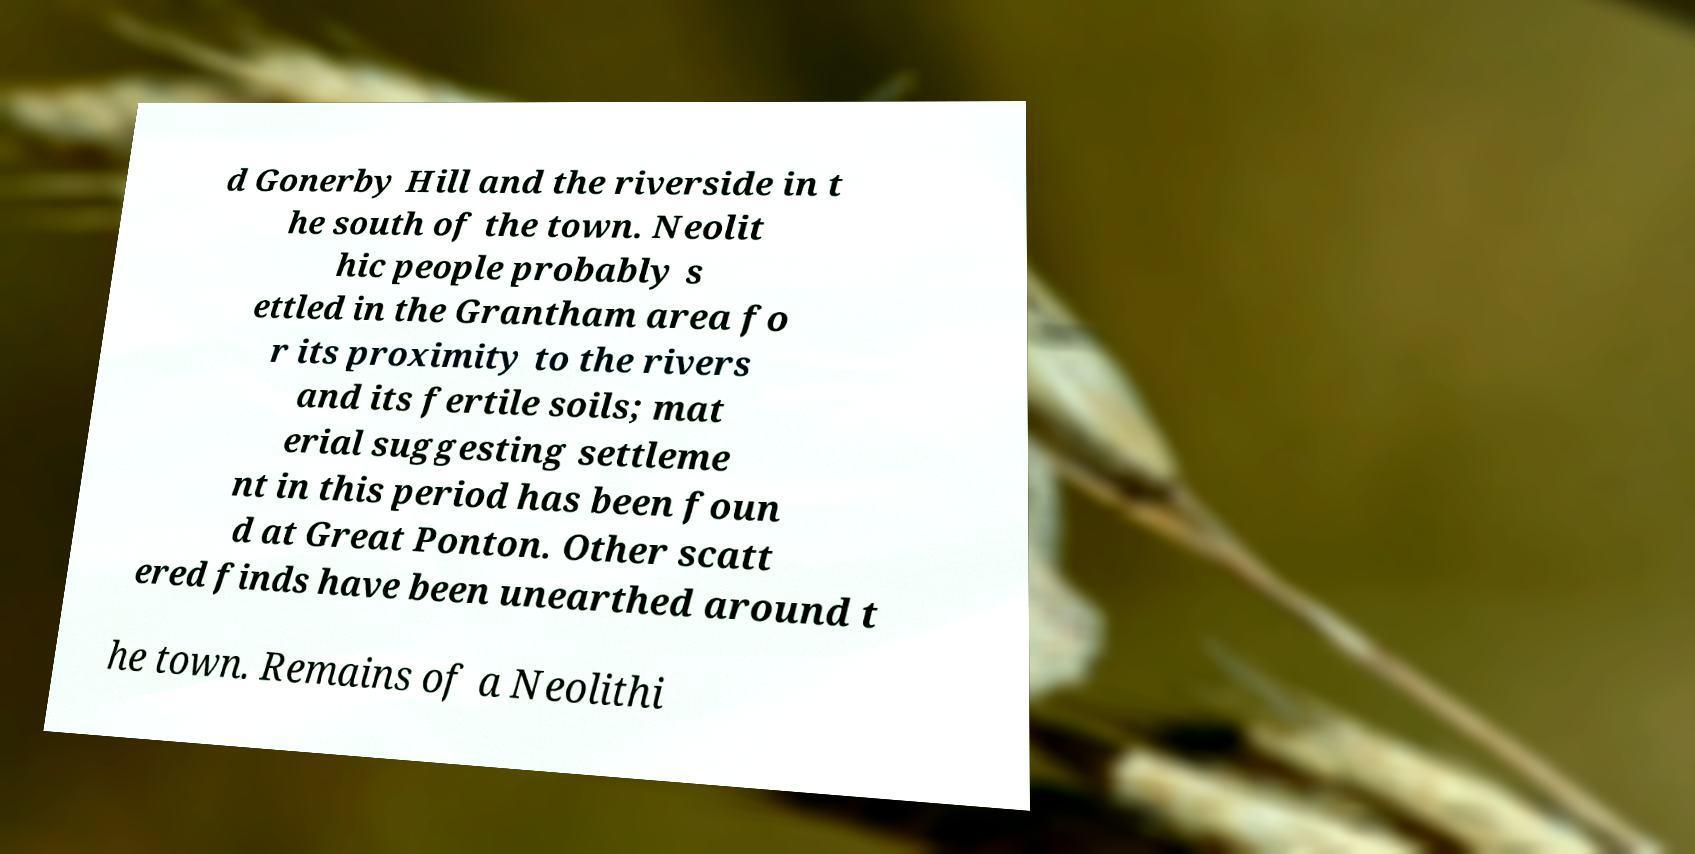What messages or text are displayed in this image? I need them in a readable, typed format. d Gonerby Hill and the riverside in t he south of the town. Neolit hic people probably s ettled in the Grantham area fo r its proximity to the rivers and its fertile soils; mat erial suggesting settleme nt in this period has been foun d at Great Ponton. Other scatt ered finds have been unearthed around t he town. Remains of a Neolithi 